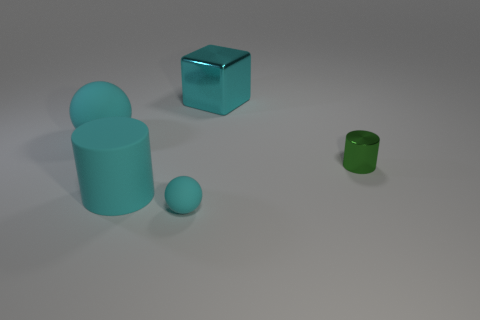Is there anything else that has the same shape as the large cyan metallic object?
Ensure brevity in your answer.  No. The big rubber thing that is the same color as the large rubber ball is what shape?
Keep it short and to the point. Cylinder. How many cyan objects have the same size as the green metallic cylinder?
Provide a succinct answer. 1. Are there fewer large shiny blocks to the left of the small rubber thing than large purple metal balls?
Make the answer very short. No. There is a big rubber cylinder; what number of cyan rubber spheres are in front of it?
Ensure brevity in your answer.  1. What is the size of the cyan rubber sphere behind the ball that is in front of the tiny thing that is right of the tiny cyan ball?
Ensure brevity in your answer.  Large. There is a small cyan rubber thing; does it have the same shape as the matte thing that is behind the rubber cylinder?
Offer a terse response. Yes. What is the size of the cylinder that is the same material as the small cyan thing?
Offer a terse response. Large. Is there anything else of the same color as the rubber cylinder?
Your answer should be compact. Yes. What material is the tiny thing on the left side of the large cyan block that is on the right side of the rubber sphere to the left of the big cyan cylinder?
Keep it short and to the point. Rubber. 